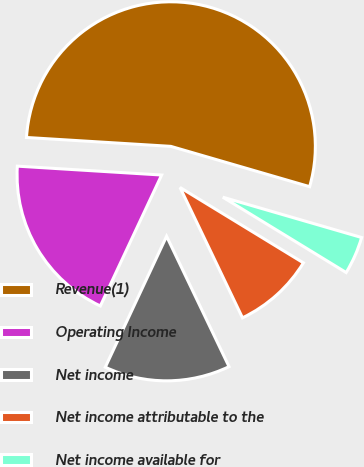Convert chart to OTSL. <chart><loc_0><loc_0><loc_500><loc_500><pie_chart><fcel>Revenue(1)<fcel>Operating Income<fcel>Net income<fcel>Net income attributable to the<fcel>Net income available for<nl><fcel>53.52%<fcel>19.01%<fcel>14.08%<fcel>9.16%<fcel>4.23%<nl></chart> 